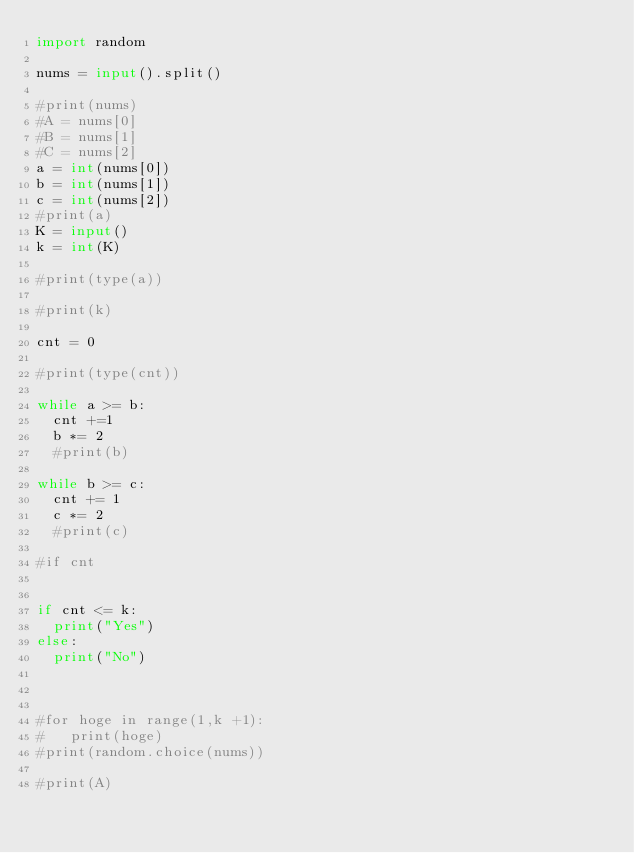<code> <loc_0><loc_0><loc_500><loc_500><_Python_>import random

nums = input().split()

#print(nums)
#A = nums[0]
#B = nums[1]
#C = nums[2]
a = int(nums[0])
b = int(nums[1])
c = int(nums[2])
#print(a)
K = input()
k = int(K)

#print(type(a))

#print(k)

cnt = 0

#print(type(cnt))

while a >= b:
  cnt +=1
  b *= 2
  #print(b)

while b >= c:
  cnt += 1
  c *= 2
  #print(c)
  
#if cnt

  
if cnt <= k:
  print("Yes")
else:
  print("No")

	

#for hoge in range(1,k +1):
#	print(hoge)
#print(random.choice(nums))

#print(A)</code> 